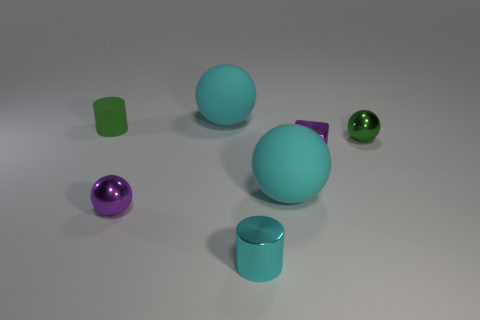Subtract 1 balls. How many balls are left? 3 Subtract all tiny purple metallic balls. How many balls are left? 3 Subtract all green balls. How many balls are left? 3 Subtract all purple spheres. Subtract all cyan cylinders. How many spheres are left? 3 Add 3 tiny gray cylinders. How many objects exist? 10 Subtract all balls. How many objects are left? 3 Subtract all red rubber cubes. Subtract all big cyan spheres. How many objects are left? 5 Add 1 tiny cubes. How many tiny cubes are left? 2 Add 4 small purple shiny blocks. How many small purple shiny blocks exist? 5 Subtract 0 blue balls. How many objects are left? 7 